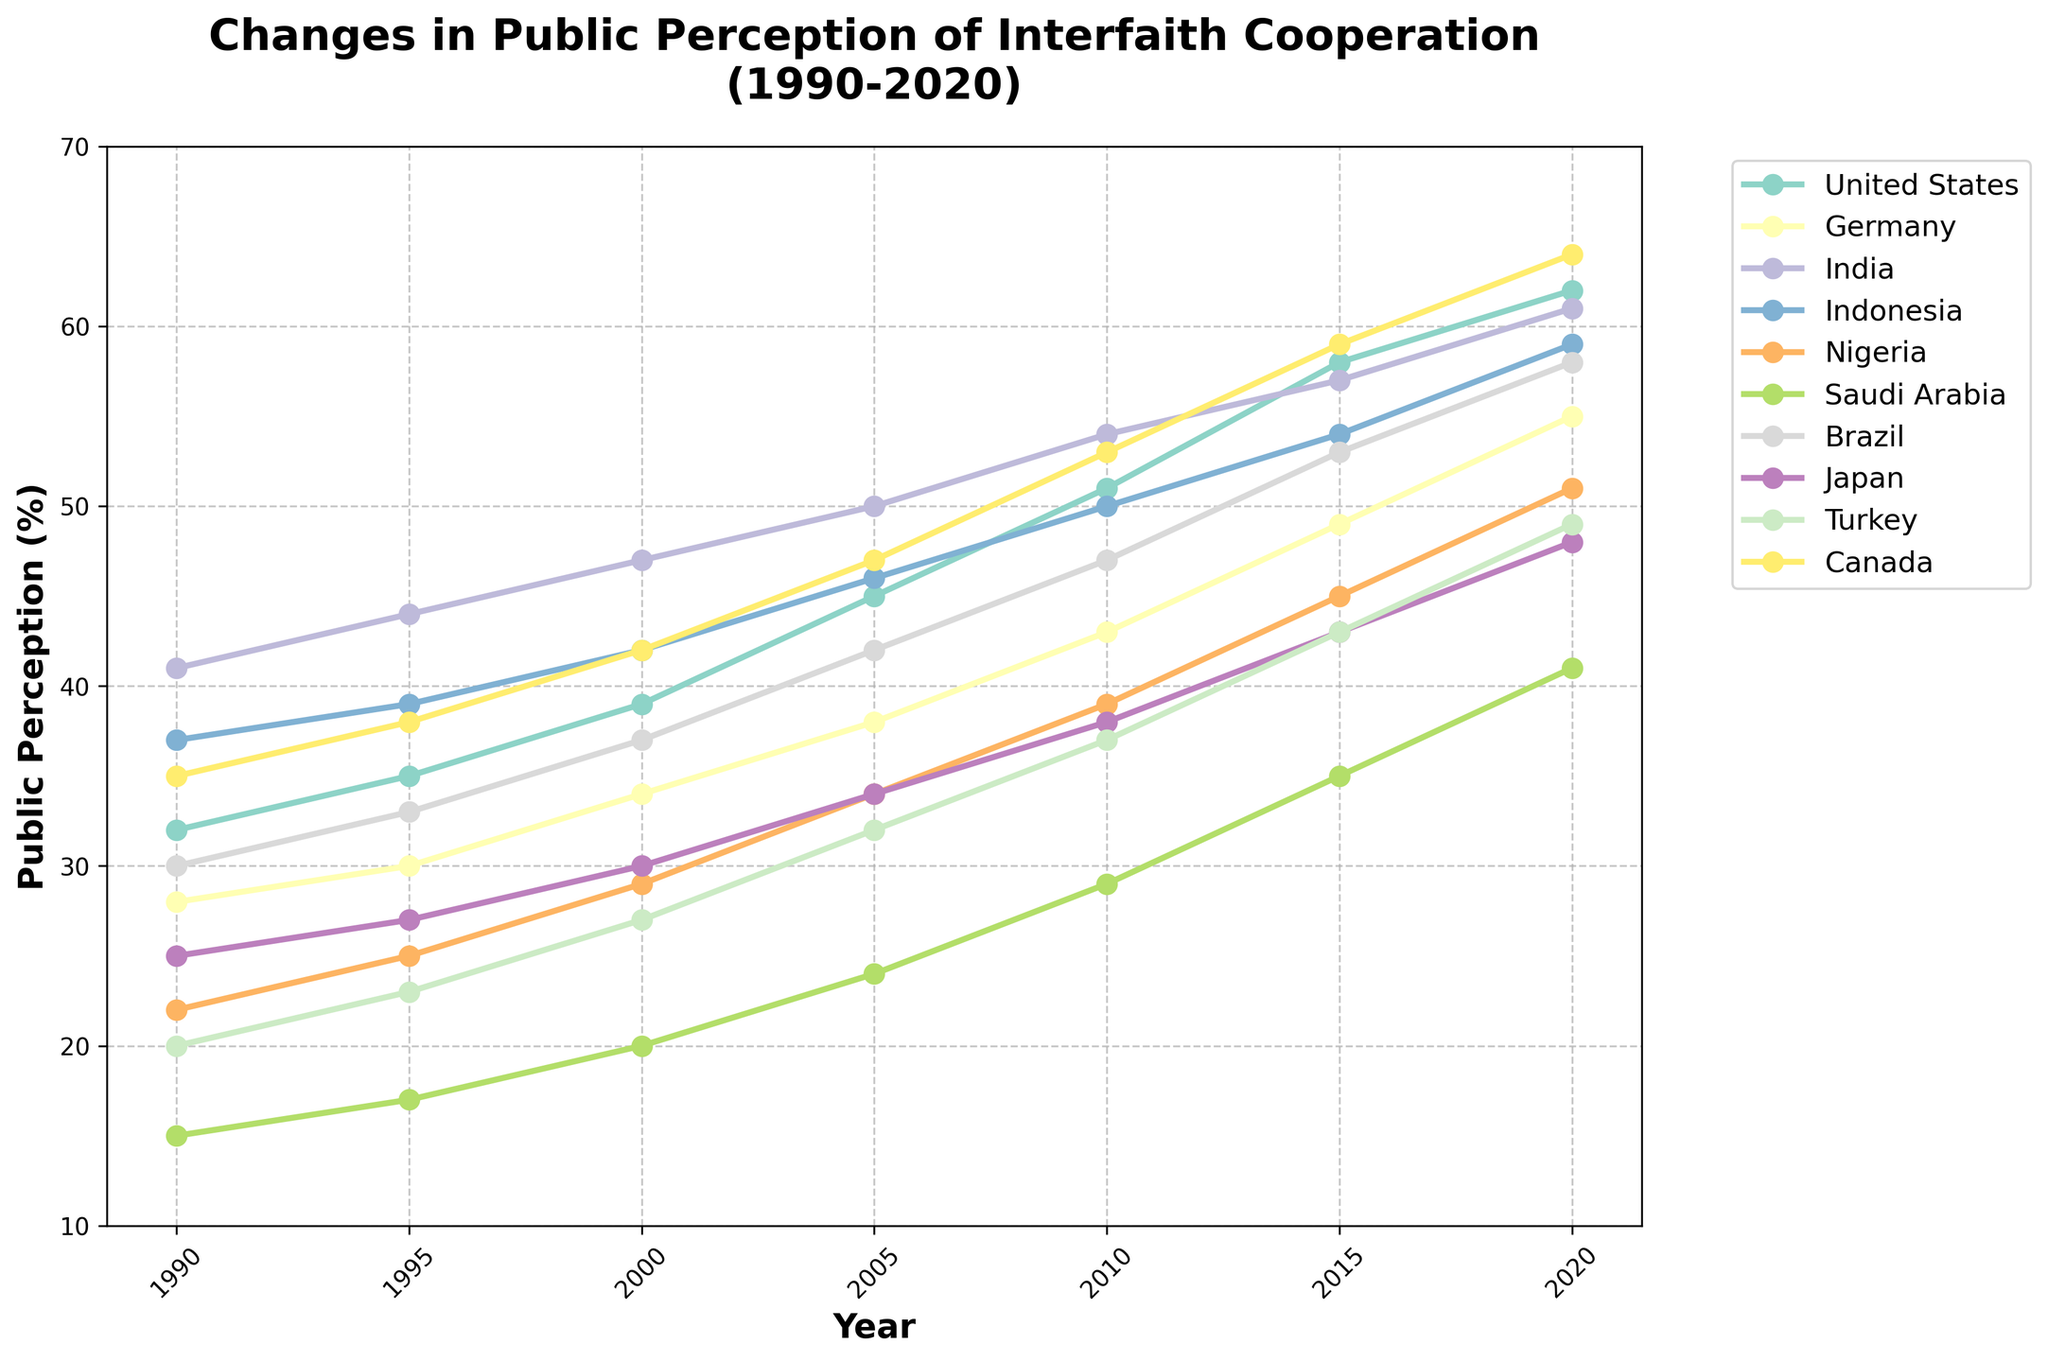What is the country with the highest public perception of interfaith cooperation in 2020? First, locate the data points for the year 2020 for all the countries. Then, identify the one with the highest value. According to the chart, Canada has the highest public perception of interfaith cooperation with a value of 64%.
Answer: Canada How much did the public perception of interfaith cooperation in Turkey increase from 1990 to 2020? First, find the value for Turkey in 1990 which is 20%. Then, find the value for Turkey in 2020 which is 49%. Subtract the 1990 value from the 2020 value: 49% - 20% = 29%. The public perception increased by 29%.
Answer: 29% What is the average public perception of interfaith cooperation for Brazil throughout the years? Sum up the perception values for Brazil across all available years and divide by the number of years: (30 + 33 + 37 + 42 + 47 + 53 + 58) / 7 = 42.85, rounded to 42.86%.
Answer: 42.86% In which year did Japan's public perception of interfaith cooperation surpass 40%? Locate Japan's perception values year by year from 1990 to 2020. The value surpasses 40% in the year 2010, when it is 43%.
Answer: 2010 Which country has the lowest starting point for public perception of interfaith cooperation in 1990? Locate the 1990 values for all countries and identify the lowest one. Saudi Arabia has the lowest value of 15% in 1990.
Answer: Saudi Arabia What is the median public perception value in the year 2015 across all countries? Find the 2015 values for all countries and list them in ascending order: 35, 43, 45, 49, 53, 54, 57, 58, 59. The median value, the middle one in an odd number of sorted values, is 53%.
Answer: 53% By how much did the public perception of interfaith cooperation increase in Saudi Arabia from 2000 to 2010? Find the values for Saudi Arabia in 2000 and 2010, then compute the difference: 29% - 20% = 9%.
Answer: 9% Compare the public perception values of the United States and Germany in 2005. Which country had a higher perception rate and by how much? Find the values for 2005 for both countries. The values are 45% for the United States and 38% for Germany. The United States has a higher perception rate by 45% - 38% = 7%.
Answer: United States, 7% 